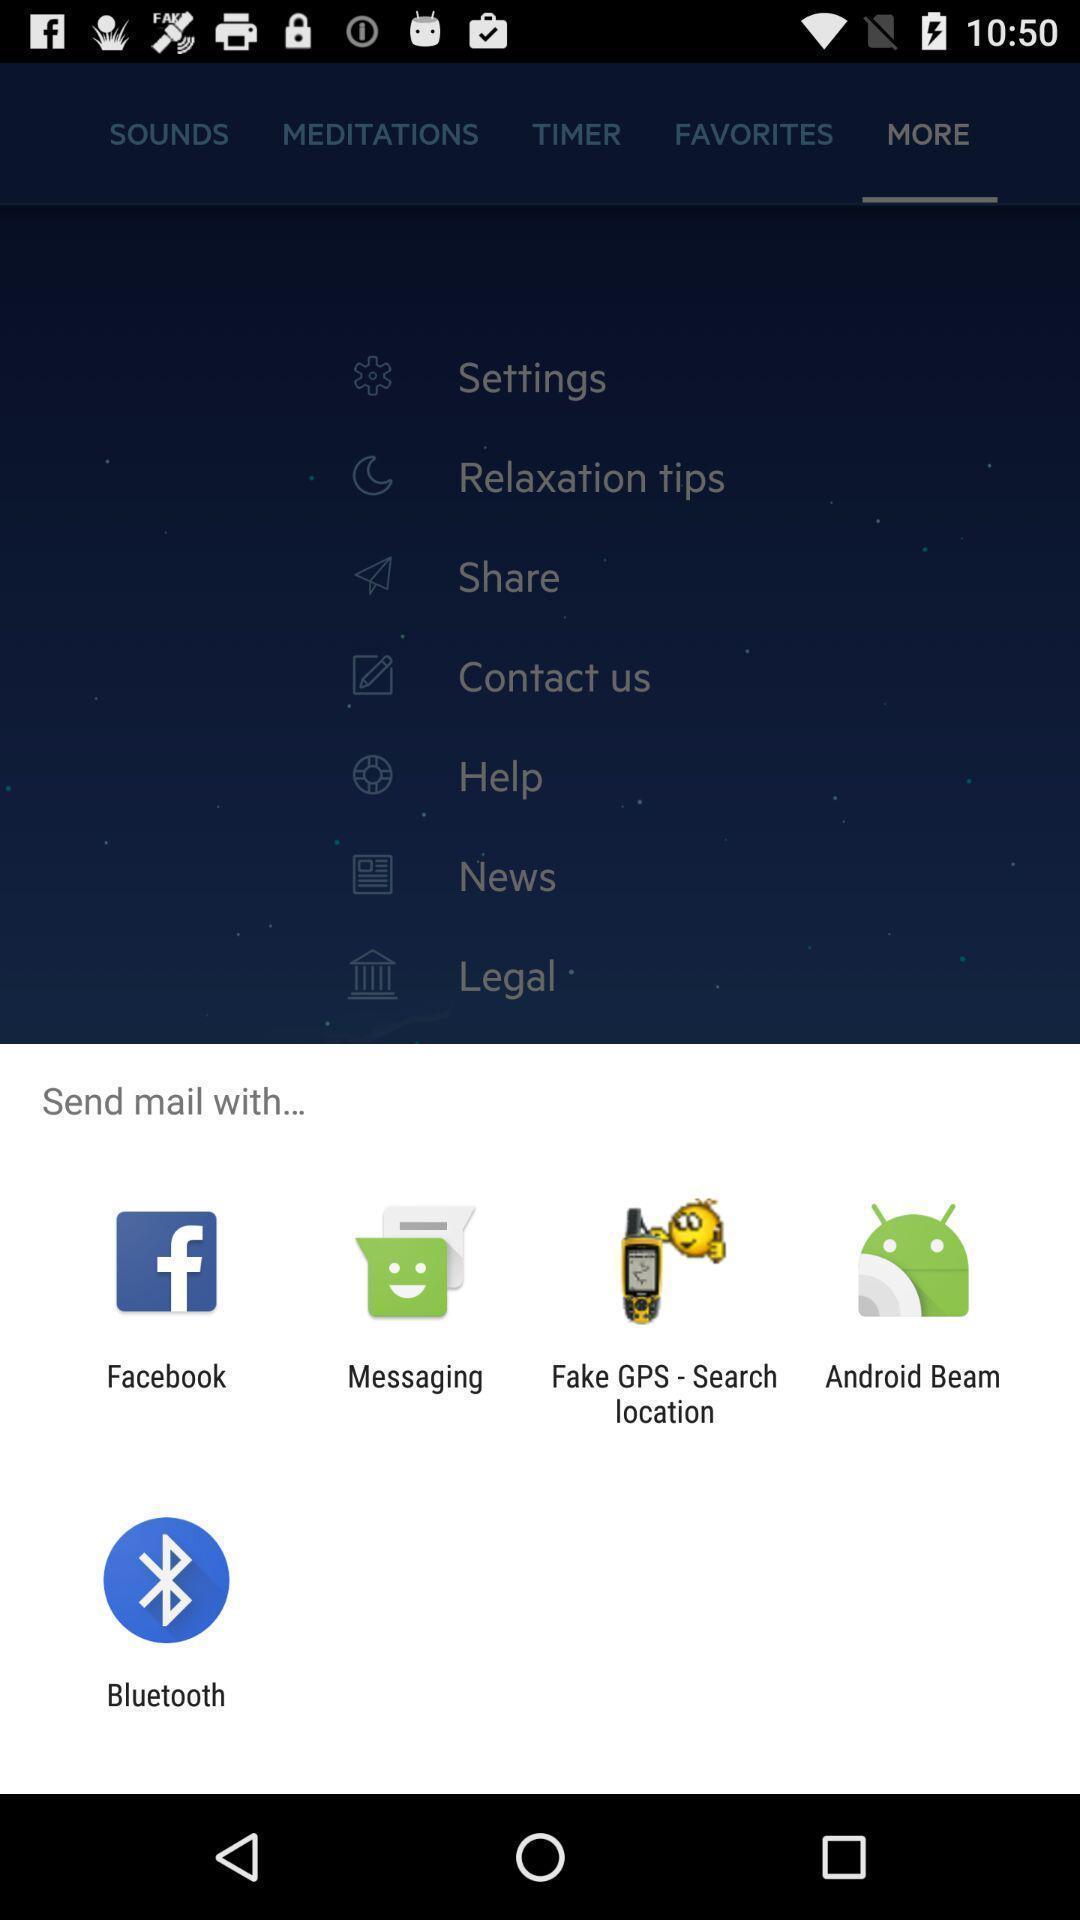What can you discern from this picture? Pop-up of various icons to send mail for insomnia app. 